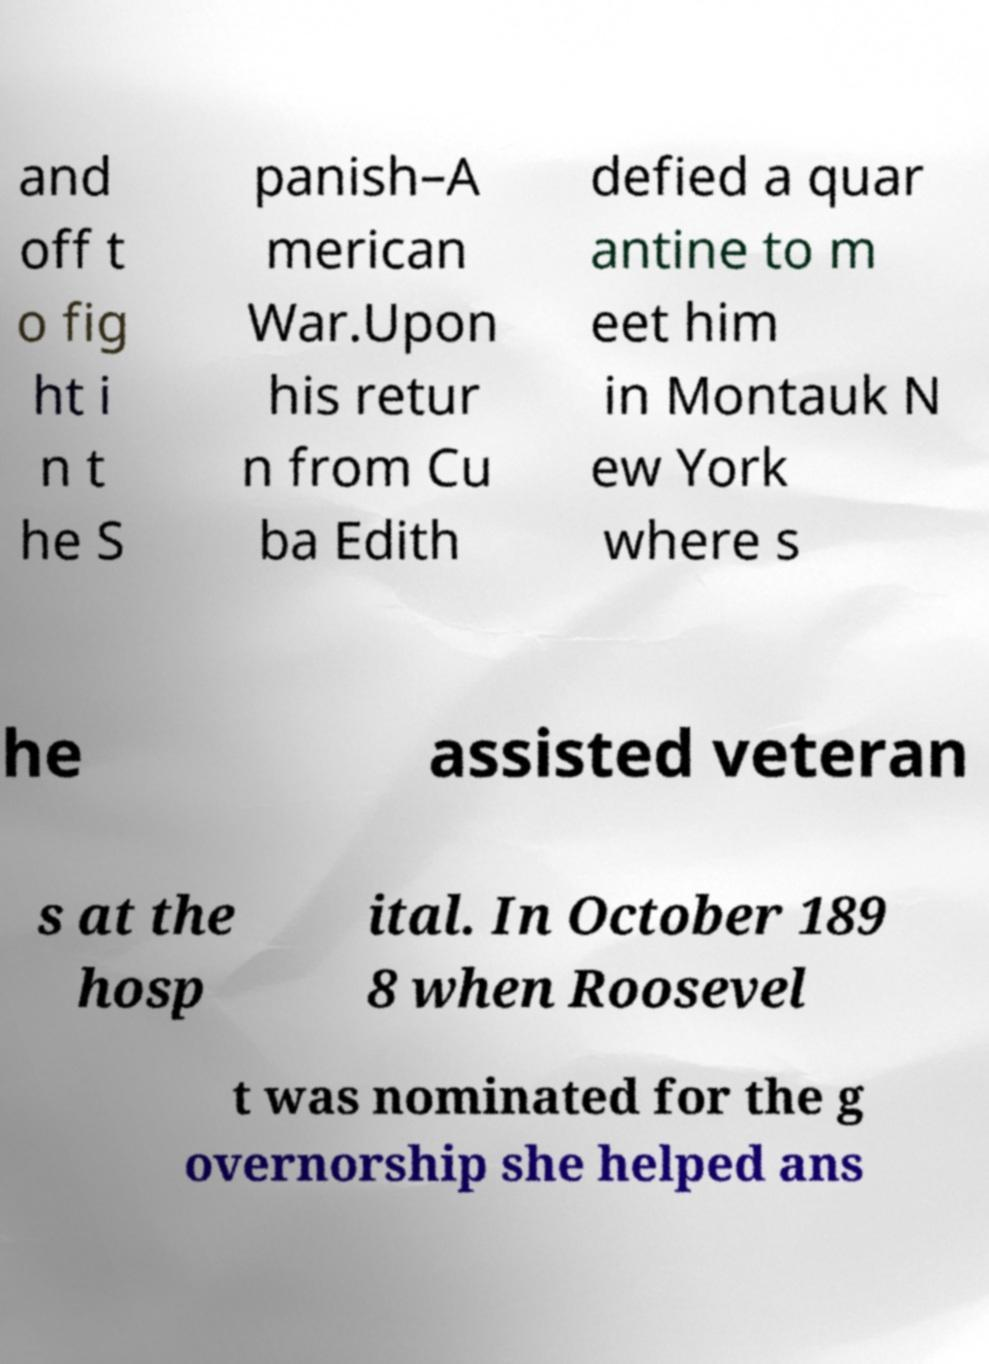Can you accurately transcribe the text from the provided image for me? and off t o fig ht i n t he S panish–A merican War.Upon his retur n from Cu ba Edith defied a quar antine to m eet him in Montauk N ew York where s he assisted veteran s at the hosp ital. In October 189 8 when Roosevel t was nominated for the g overnorship she helped ans 